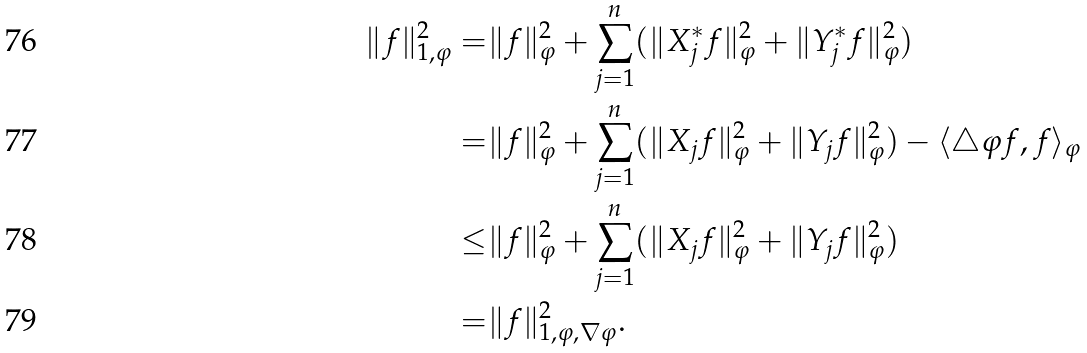<formula> <loc_0><loc_0><loc_500><loc_500>\| f \| _ { 1 , \varphi } ^ { 2 } = & \| f \| ^ { 2 } _ { \varphi } + \sum _ { j = 1 } ^ { n } ( \| X ^ { * } _ { j } f \| _ { \varphi } ^ { 2 } + \| Y ^ { * } _ { j } f \| _ { \varphi } ^ { 2 } ) \\ = & \| f \| ^ { 2 } _ { \varphi } + \sum _ { j = 1 } ^ { n } ( \| X _ { j } f \| _ { \varphi } ^ { 2 } + \| Y _ { j } f \| _ { \varphi } ^ { 2 } ) - \langle \triangle \varphi f , f \rangle _ { \varphi } \\ \leq & \| f \| ^ { 2 } _ { \varphi } + \sum _ { j = 1 } ^ { n } ( \| X _ { j } f \| _ { \varphi } ^ { 2 } + \| Y _ { j } f \| _ { \varphi } ^ { 2 } ) \\ = & \| f \| ^ { 2 } _ { 1 , \varphi , \nabla \varphi } .</formula> 